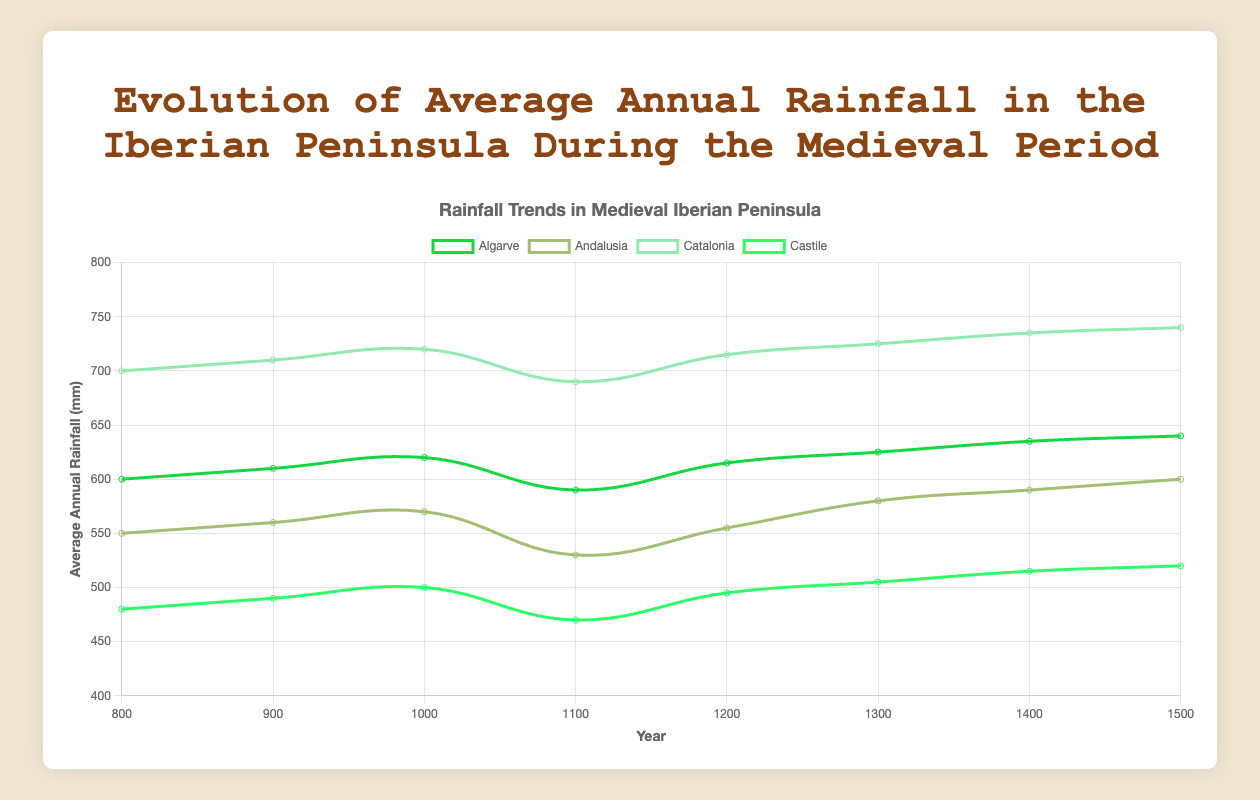What is the average annual rainfall in Catalonia in the year 1200? First, find the data point for Catalonia in 1200. It is listed as 715 mm. Thus, the average annual rainfall in Catalonia in 1200 is 715 mm.
Answer: 715 mm Which region experienced the highest average annual rainfall in the year 1300? Look at the data for all regions in 1300: Algarve (625 mm), Andalusia (580 mm), Catalonia (725 mm), and Castile (505 mm). Catalonia has the highest average annual rainfall with 725 mm.
Answer: Catalonia How did the average annual rainfall in Castile change from 1100 to 1500? Subtract the rainfall in 1100 (470 mm) from the rainfall in 1500 (520 mm). The change is 520 - 470 = 50 mm, meaning it increased by 50 mm.
Answer: Increased by 50 mm Between the years 1200 and 1300, which region saw the greatest increase in average annual rainfall? Calculate the difference for each region: 
Algarve: 625 - 615 = 10 mm
Andalusia: 580 - 555 = 25 mm
Catalonia: 725 - 715 = 10 mm
Castile: 505 - 495 = 10 mm
Andalusia saw the greatest increase of 25 mm.
Answer: Andalusia What is the median average annual rainfall for Andalusia from 800 to 1500? List the values for Andalusia (550, 560, 570, 530, 555, 580, 590, 600) and sort them (530, 550, 555, 560, 570, 580, 590, 600). Since there are 8 numbers, the median is the average of the 4th and 5th values: (560 + 570)/2 = 565 mm.
Answer: 565 mm Which region had the lowest average annual rainfall overall, and what was its minimum value? Look through all the data points for the regions:
Algarve: Min 590 mm
Andalusia: Min 530 mm
Catalonia: Min 690 mm
Castile: Min 470 mm
Castile had the lowest overall minimum value of 470 mm.
Answer: Castile (470 mm) How does the average annual rainfall in Algarve in the year 900 compare to that in 1300? Look at the values: 
In 900, it was 610 mm, 
In 1300, it was 625 mm.
610 mm is less than 625 mm, so the average annual rainfall increased.
Answer: Increased Which region shows the most significant fluctuation in average annual rainfall from 800 to 1500? Calculate the range (maximum minus minimum) for each region:
Algarve: 640 - 590 = 50 mm
Andalusia: 600 - 530 = 70 mm 
Catalonia: 740 - 690 = 50 mm
Castile: 520 - 470 = 50 mm
Andalusia shows the most significant fluctuation with a range of 70 mm.
Answer: Andalusia What is the trend in Catalonia's average annual rainfall from 800 to 1500? Observe the values in Catalonia: 
700 (800), 710 (900), 720 (1000), 690 (1100), 715 (1200), 725 (1300), 735 (1400), 740 (1500).
Overall, the trend shows an increase, despite a brief decline around 1100.
Answer: Increasing Compare the average annual rainfall in the four regions in the year 1000. Which had the highest and which had the lowest? Look at the values for the year 1000:
Algarve: 620 mm
Andalusia: 570 mm
Catalonia: 720 mm
Castile: 500 mm
Catalonia had the highest average annual rainfall, and Castile had the lowest.
Answer: Catalonia (highest), Castile (lowest) 